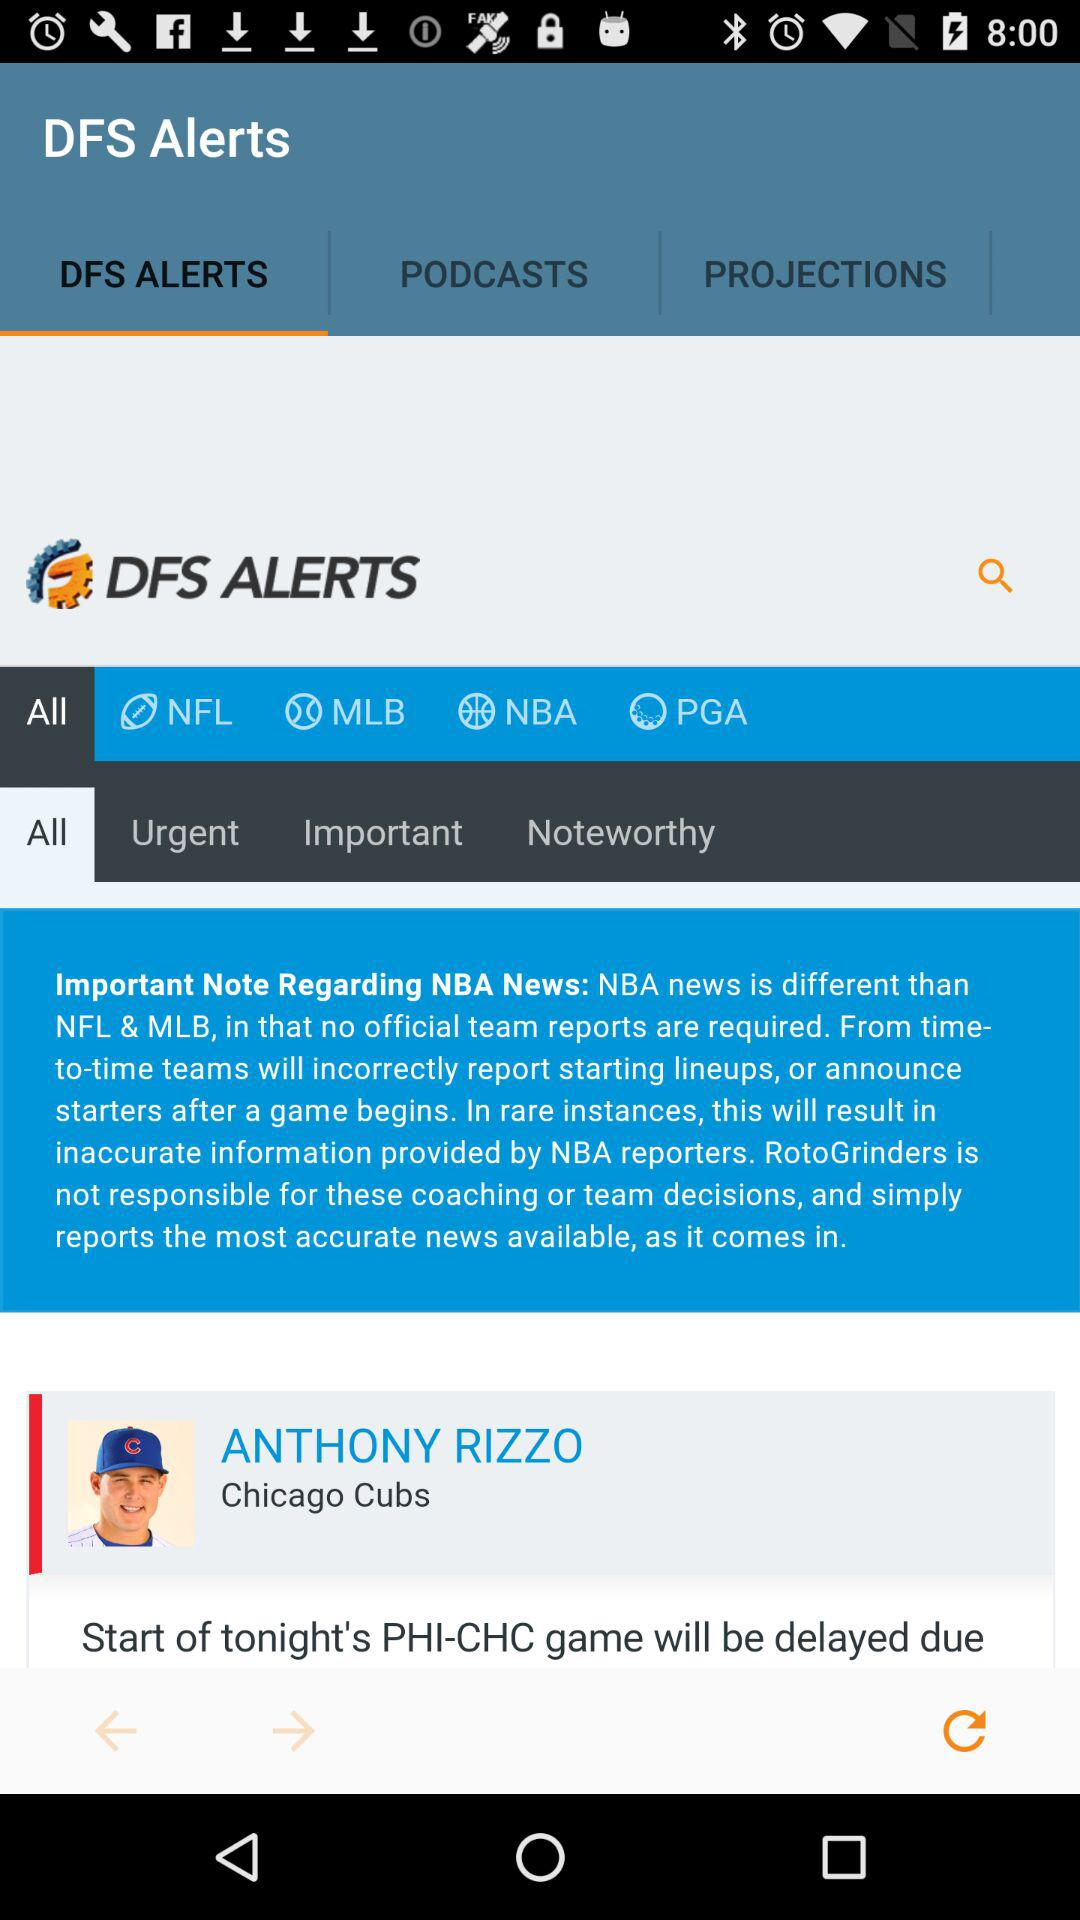What is the name of the "Chicago Cubs" player? The name of the "Chicago Cubs" player is Anthony Rizzo. 